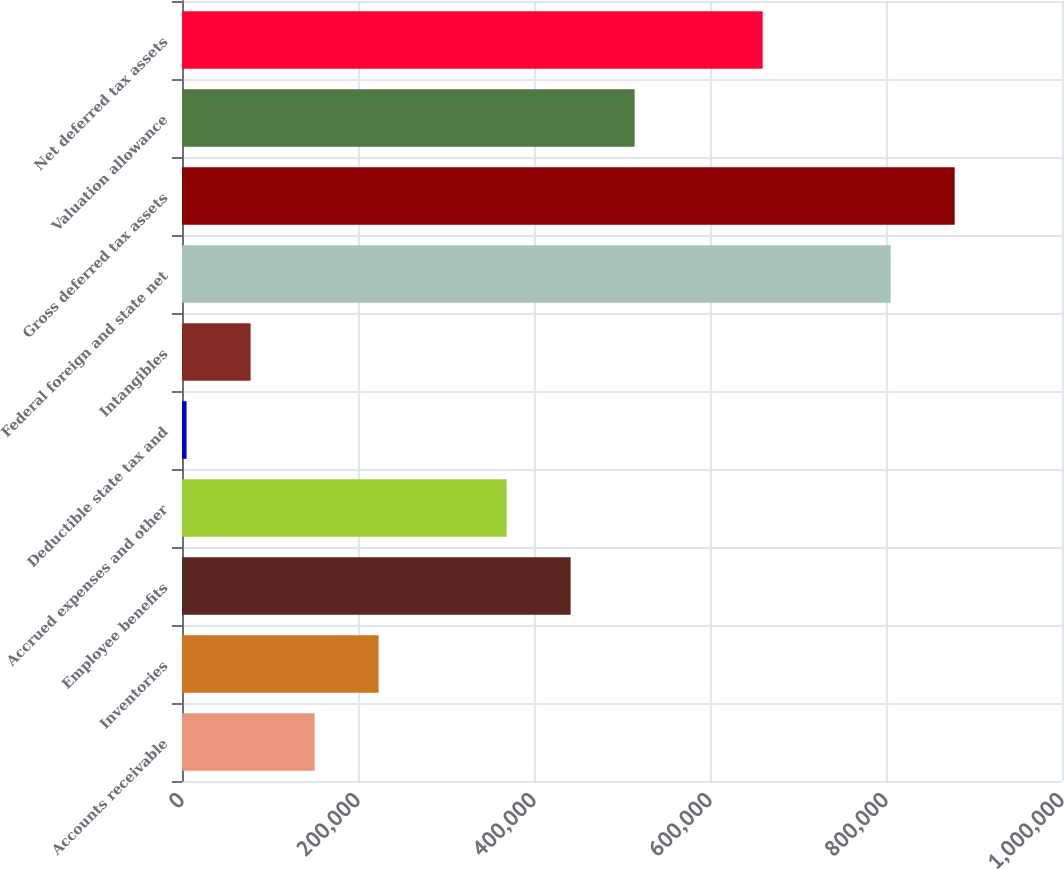Convert chart. <chart><loc_0><loc_0><loc_500><loc_500><bar_chart><fcel>Accounts receivable<fcel>Inventories<fcel>Employee benefits<fcel>Accrued expenses and other<fcel>Deductible state tax and<fcel>Intangibles<fcel>Federal foreign and state net<fcel>Gross deferred tax assets<fcel>Valuation allowance<fcel>Net deferred tax assets<nl><fcel>150662<fcel>223400<fcel>441614<fcel>368876<fcel>5186<fcel>77924<fcel>805304<fcel>878042<fcel>514352<fcel>659828<nl></chart> 